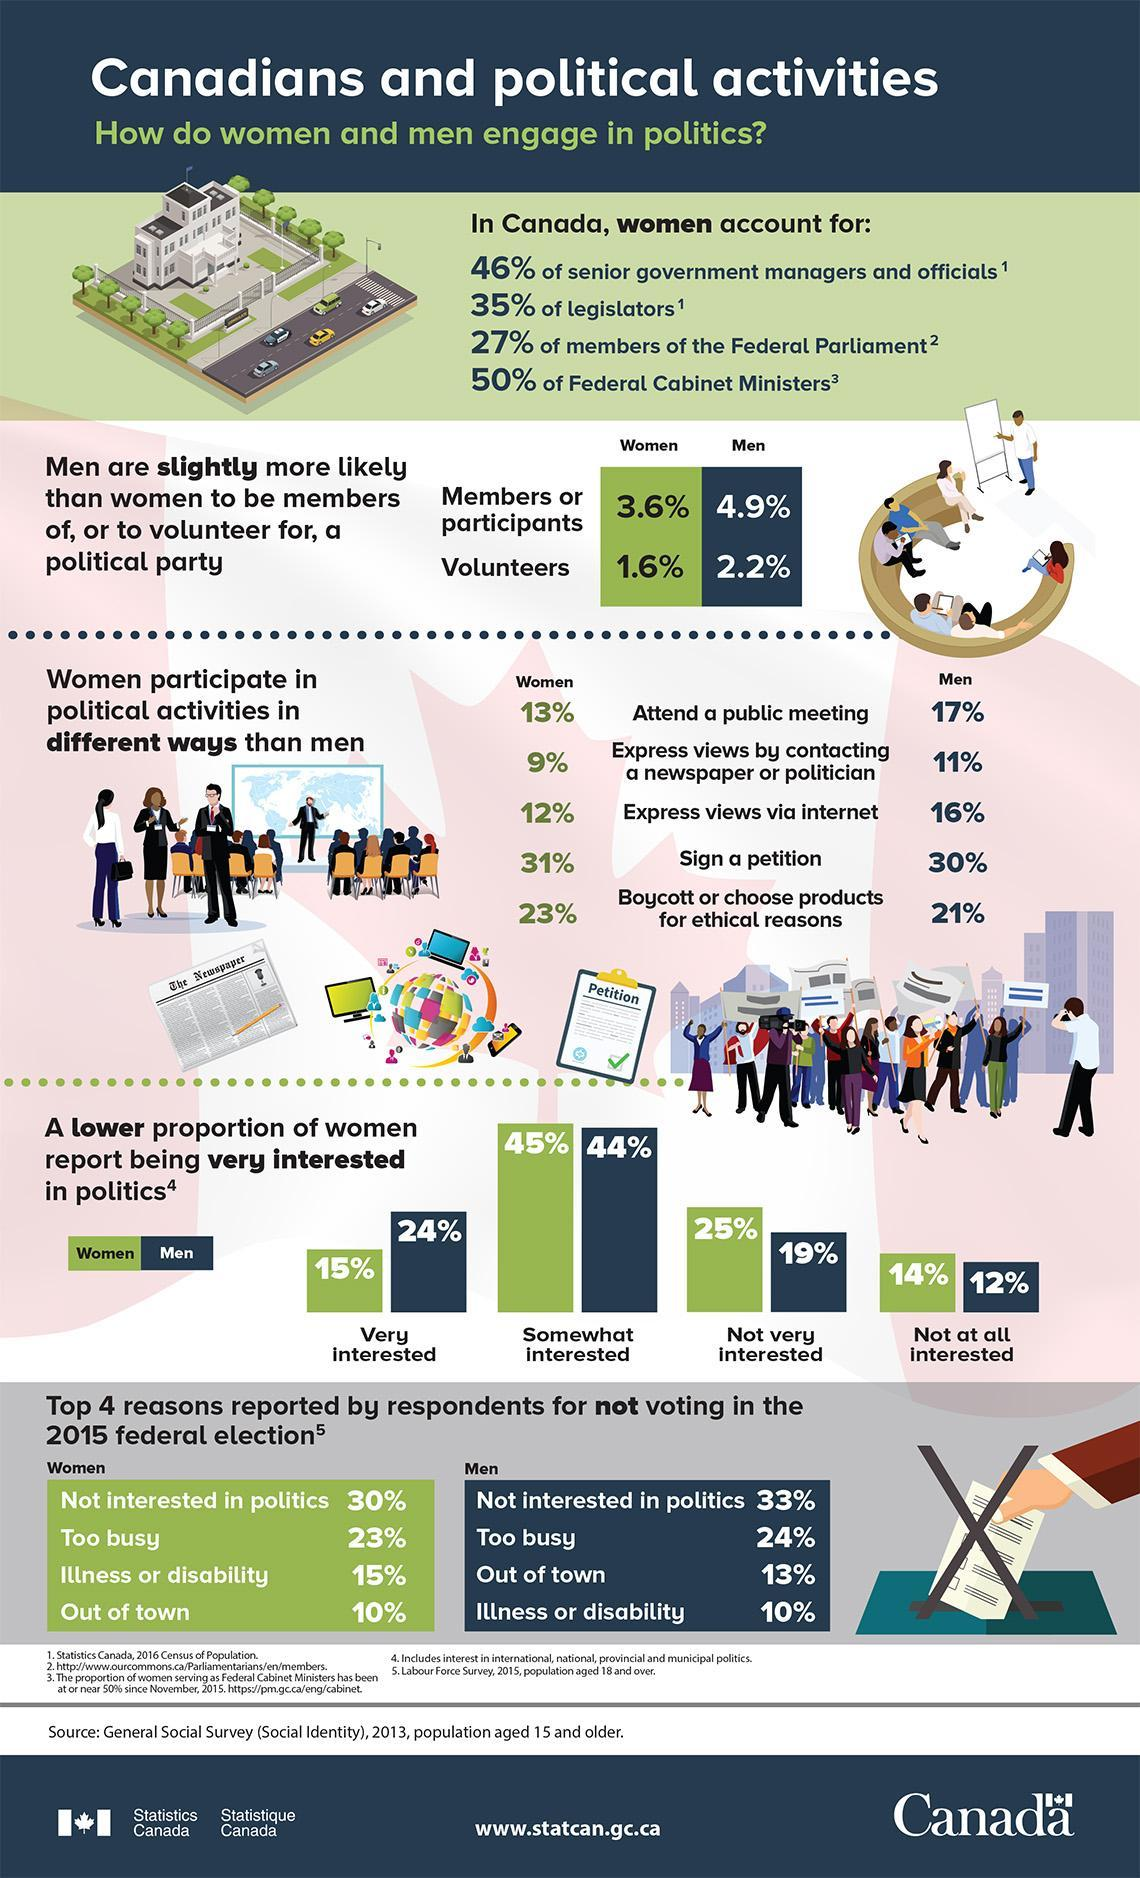What percentage of Canadian women are very interested in politics according to the General Social Survey in 2013?
Answer the question with a short phrase. 15% What percentage of the Canadian men are members or participants of a political party according to the General Social Survey in 2013? 4.9% What percentage of Canadian men are somewhat interested in politics according to the Survey? 44% What percent of the Canadian women volunteer for a political party according to the survey? 1.6% What percent of Canadian women didn't vote for the 2015 federal election due to illness or disability as per the Labour Force Survey, 2015? 15% What percent of legislators in Canada are women according to the 2016 Census of Population? 35% What percent of Canadian men express political views through internet according to the General Social Survey in 2013? 16% 